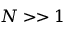Convert formula to latex. <formula><loc_0><loc_0><loc_500><loc_500>N > > 1</formula> 